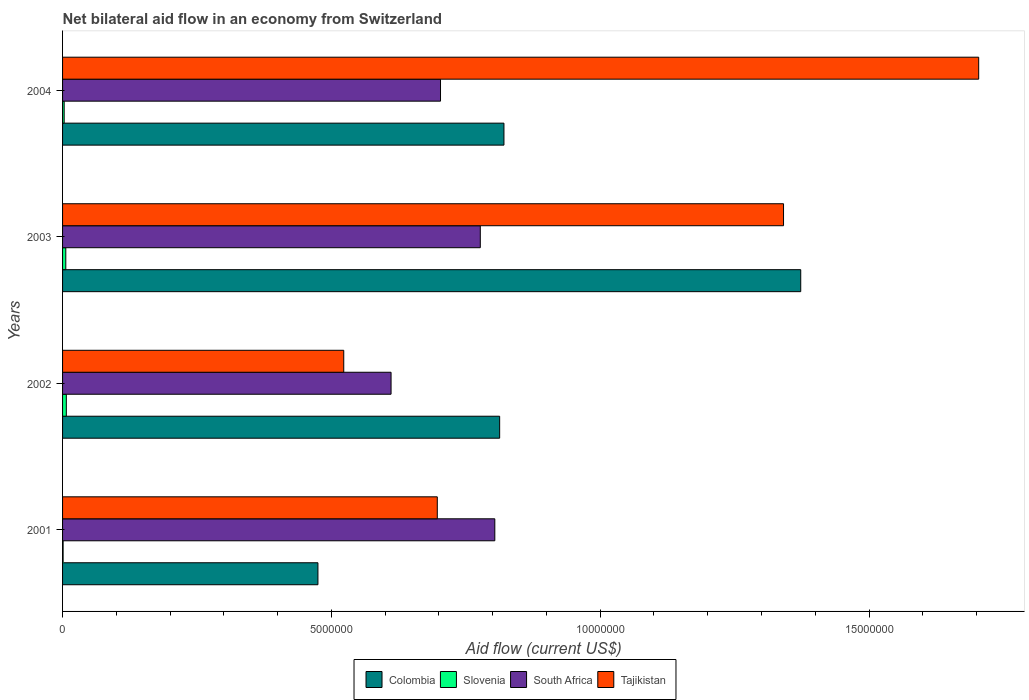How many groups of bars are there?
Ensure brevity in your answer.  4. Are the number of bars per tick equal to the number of legend labels?
Offer a terse response. Yes. How many bars are there on the 1st tick from the bottom?
Make the answer very short. 4. What is the label of the 4th group of bars from the top?
Make the answer very short. 2001. What is the net bilateral aid flow in Slovenia in 2003?
Provide a short and direct response. 6.00e+04. Across all years, what is the maximum net bilateral aid flow in Slovenia?
Provide a succinct answer. 7.00e+04. Across all years, what is the minimum net bilateral aid flow in South Africa?
Provide a succinct answer. 6.11e+06. In which year was the net bilateral aid flow in South Africa minimum?
Ensure brevity in your answer.  2002. What is the total net bilateral aid flow in South Africa in the graph?
Your response must be concise. 2.90e+07. What is the difference between the net bilateral aid flow in South Africa in 2002 and that in 2003?
Your answer should be very brief. -1.66e+06. What is the difference between the net bilateral aid flow in Colombia in 2001 and the net bilateral aid flow in Tajikistan in 2003?
Provide a succinct answer. -8.66e+06. What is the average net bilateral aid flow in South Africa per year?
Your response must be concise. 7.24e+06. In the year 2002, what is the difference between the net bilateral aid flow in Slovenia and net bilateral aid flow in Tajikistan?
Offer a terse response. -5.16e+06. What is the ratio of the net bilateral aid flow in Slovenia in 2002 to that in 2003?
Ensure brevity in your answer.  1.17. Is the net bilateral aid flow in Colombia in 2001 less than that in 2002?
Make the answer very short. Yes. Is the difference between the net bilateral aid flow in Slovenia in 2001 and 2003 greater than the difference between the net bilateral aid flow in Tajikistan in 2001 and 2003?
Offer a very short reply. Yes. What is the difference between the highest and the second highest net bilateral aid flow in Colombia?
Your answer should be compact. 5.52e+06. Is the sum of the net bilateral aid flow in Tajikistan in 2001 and 2002 greater than the maximum net bilateral aid flow in South Africa across all years?
Provide a short and direct response. Yes. Is it the case that in every year, the sum of the net bilateral aid flow in Tajikistan and net bilateral aid flow in Slovenia is greater than the sum of net bilateral aid flow in Colombia and net bilateral aid flow in South Africa?
Make the answer very short. No. What does the 1st bar from the top in 2004 represents?
Your answer should be compact. Tajikistan. What does the 3rd bar from the bottom in 2004 represents?
Offer a very short reply. South Africa. Is it the case that in every year, the sum of the net bilateral aid flow in Tajikistan and net bilateral aid flow in South Africa is greater than the net bilateral aid flow in Slovenia?
Ensure brevity in your answer.  Yes. How many years are there in the graph?
Make the answer very short. 4. Where does the legend appear in the graph?
Offer a very short reply. Bottom center. How are the legend labels stacked?
Provide a short and direct response. Horizontal. What is the title of the graph?
Keep it short and to the point. Net bilateral aid flow in an economy from Switzerland. Does "Uganda" appear as one of the legend labels in the graph?
Offer a very short reply. No. What is the label or title of the X-axis?
Provide a succinct answer. Aid flow (current US$). What is the label or title of the Y-axis?
Give a very brief answer. Years. What is the Aid flow (current US$) in Colombia in 2001?
Keep it short and to the point. 4.75e+06. What is the Aid flow (current US$) of Slovenia in 2001?
Provide a succinct answer. 10000. What is the Aid flow (current US$) of South Africa in 2001?
Offer a very short reply. 8.04e+06. What is the Aid flow (current US$) of Tajikistan in 2001?
Your answer should be compact. 6.97e+06. What is the Aid flow (current US$) in Colombia in 2002?
Your answer should be very brief. 8.13e+06. What is the Aid flow (current US$) in South Africa in 2002?
Give a very brief answer. 6.11e+06. What is the Aid flow (current US$) in Tajikistan in 2002?
Provide a short and direct response. 5.23e+06. What is the Aid flow (current US$) in Colombia in 2003?
Provide a short and direct response. 1.37e+07. What is the Aid flow (current US$) of South Africa in 2003?
Give a very brief answer. 7.77e+06. What is the Aid flow (current US$) in Tajikistan in 2003?
Your answer should be very brief. 1.34e+07. What is the Aid flow (current US$) of Colombia in 2004?
Your answer should be very brief. 8.21e+06. What is the Aid flow (current US$) of South Africa in 2004?
Offer a terse response. 7.03e+06. What is the Aid flow (current US$) of Tajikistan in 2004?
Provide a short and direct response. 1.70e+07. Across all years, what is the maximum Aid flow (current US$) in Colombia?
Provide a succinct answer. 1.37e+07. Across all years, what is the maximum Aid flow (current US$) of Slovenia?
Provide a short and direct response. 7.00e+04. Across all years, what is the maximum Aid flow (current US$) in South Africa?
Make the answer very short. 8.04e+06. Across all years, what is the maximum Aid flow (current US$) of Tajikistan?
Offer a very short reply. 1.70e+07. Across all years, what is the minimum Aid flow (current US$) of Colombia?
Your answer should be compact. 4.75e+06. Across all years, what is the minimum Aid flow (current US$) of South Africa?
Your answer should be very brief. 6.11e+06. Across all years, what is the minimum Aid flow (current US$) of Tajikistan?
Your answer should be compact. 5.23e+06. What is the total Aid flow (current US$) of Colombia in the graph?
Provide a short and direct response. 3.48e+07. What is the total Aid flow (current US$) in South Africa in the graph?
Offer a very short reply. 2.90e+07. What is the total Aid flow (current US$) of Tajikistan in the graph?
Provide a short and direct response. 4.26e+07. What is the difference between the Aid flow (current US$) in Colombia in 2001 and that in 2002?
Your response must be concise. -3.38e+06. What is the difference between the Aid flow (current US$) of South Africa in 2001 and that in 2002?
Provide a succinct answer. 1.93e+06. What is the difference between the Aid flow (current US$) of Tajikistan in 2001 and that in 2002?
Give a very brief answer. 1.74e+06. What is the difference between the Aid flow (current US$) in Colombia in 2001 and that in 2003?
Offer a very short reply. -8.98e+06. What is the difference between the Aid flow (current US$) of Slovenia in 2001 and that in 2003?
Give a very brief answer. -5.00e+04. What is the difference between the Aid flow (current US$) of Tajikistan in 2001 and that in 2003?
Your response must be concise. -6.44e+06. What is the difference between the Aid flow (current US$) of Colombia in 2001 and that in 2004?
Your response must be concise. -3.46e+06. What is the difference between the Aid flow (current US$) in South Africa in 2001 and that in 2004?
Ensure brevity in your answer.  1.01e+06. What is the difference between the Aid flow (current US$) in Tajikistan in 2001 and that in 2004?
Provide a short and direct response. -1.01e+07. What is the difference between the Aid flow (current US$) in Colombia in 2002 and that in 2003?
Your response must be concise. -5.60e+06. What is the difference between the Aid flow (current US$) in Slovenia in 2002 and that in 2003?
Offer a terse response. 10000. What is the difference between the Aid flow (current US$) in South Africa in 2002 and that in 2003?
Your answer should be compact. -1.66e+06. What is the difference between the Aid flow (current US$) in Tajikistan in 2002 and that in 2003?
Offer a terse response. -8.18e+06. What is the difference between the Aid flow (current US$) of Colombia in 2002 and that in 2004?
Your answer should be very brief. -8.00e+04. What is the difference between the Aid flow (current US$) in Slovenia in 2002 and that in 2004?
Provide a short and direct response. 4.00e+04. What is the difference between the Aid flow (current US$) of South Africa in 2002 and that in 2004?
Your response must be concise. -9.20e+05. What is the difference between the Aid flow (current US$) of Tajikistan in 2002 and that in 2004?
Make the answer very short. -1.18e+07. What is the difference between the Aid flow (current US$) of Colombia in 2003 and that in 2004?
Keep it short and to the point. 5.52e+06. What is the difference between the Aid flow (current US$) in Slovenia in 2003 and that in 2004?
Your answer should be very brief. 3.00e+04. What is the difference between the Aid flow (current US$) of South Africa in 2003 and that in 2004?
Provide a short and direct response. 7.40e+05. What is the difference between the Aid flow (current US$) in Tajikistan in 2003 and that in 2004?
Offer a terse response. -3.63e+06. What is the difference between the Aid flow (current US$) of Colombia in 2001 and the Aid flow (current US$) of Slovenia in 2002?
Give a very brief answer. 4.68e+06. What is the difference between the Aid flow (current US$) of Colombia in 2001 and the Aid flow (current US$) of South Africa in 2002?
Keep it short and to the point. -1.36e+06. What is the difference between the Aid flow (current US$) in Colombia in 2001 and the Aid flow (current US$) in Tajikistan in 2002?
Offer a very short reply. -4.80e+05. What is the difference between the Aid flow (current US$) of Slovenia in 2001 and the Aid flow (current US$) of South Africa in 2002?
Give a very brief answer. -6.10e+06. What is the difference between the Aid flow (current US$) in Slovenia in 2001 and the Aid flow (current US$) in Tajikistan in 2002?
Keep it short and to the point. -5.22e+06. What is the difference between the Aid flow (current US$) in South Africa in 2001 and the Aid flow (current US$) in Tajikistan in 2002?
Your response must be concise. 2.81e+06. What is the difference between the Aid flow (current US$) in Colombia in 2001 and the Aid flow (current US$) in Slovenia in 2003?
Make the answer very short. 4.69e+06. What is the difference between the Aid flow (current US$) in Colombia in 2001 and the Aid flow (current US$) in South Africa in 2003?
Your answer should be very brief. -3.02e+06. What is the difference between the Aid flow (current US$) in Colombia in 2001 and the Aid flow (current US$) in Tajikistan in 2003?
Your answer should be very brief. -8.66e+06. What is the difference between the Aid flow (current US$) in Slovenia in 2001 and the Aid flow (current US$) in South Africa in 2003?
Provide a short and direct response. -7.76e+06. What is the difference between the Aid flow (current US$) of Slovenia in 2001 and the Aid flow (current US$) of Tajikistan in 2003?
Your answer should be compact. -1.34e+07. What is the difference between the Aid flow (current US$) of South Africa in 2001 and the Aid flow (current US$) of Tajikistan in 2003?
Provide a short and direct response. -5.37e+06. What is the difference between the Aid flow (current US$) in Colombia in 2001 and the Aid flow (current US$) in Slovenia in 2004?
Your response must be concise. 4.72e+06. What is the difference between the Aid flow (current US$) in Colombia in 2001 and the Aid flow (current US$) in South Africa in 2004?
Keep it short and to the point. -2.28e+06. What is the difference between the Aid flow (current US$) in Colombia in 2001 and the Aid flow (current US$) in Tajikistan in 2004?
Give a very brief answer. -1.23e+07. What is the difference between the Aid flow (current US$) of Slovenia in 2001 and the Aid flow (current US$) of South Africa in 2004?
Provide a short and direct response. -7.02e+06. What is the difference between the Aid flow (current US$) in Slovenia in 2001 and the Aid flow (current US$) in Tajikistan in 2004?
Make the answer very short. -1.70e+07. What is the difference between the Aid flow (current US$) in South Africa in 2001 and the Aid flow (current US$) in Tajikistan in 2004?
Offer a terse response. -9.00e+06. What is the difference between the Aid flow (current US$) of Colombia in 2002 and the Aid flow (current US$) of Slovenia in 2003?
Give a very brief answer. 8.07e+06. What is the difference between the Aid flow (current US$) of Colombia in 2002 and the Aid flow (current US$) of South Africa in 2003?
Your response must be concise. 3.60e+05. What is the difference between the Aid flow (current US$) in Colombia in 2002 and the Aid flow (current US$) in Tajikistan in 2003?
Your answer should be compact. -5.28e+06. What is the difference between the Aid flow (current US$) in Slovenia in 2002 and the Aid flow (current US$) in South Africa in 2003?
Provide a succinct answer. -7.70e+06. What is the difference between the Aid flow (current US$) of Slovenia in 2002 and the Aid flow (current US$) of Tajikistan in 2003?
Offer a very short reply. -1.33e+07. What is the difference between the Aid flow (current US$) in South Africa in 2002 and the Aid flow (current US$) in Tajikistan in 2003?
Keep it short and to the point. -7.30e+06. What is the difference between the Aid flow (current US$) in Colombia in 2002 and the Aid flow (current US$) in Slovenia in 2004?
Give a very brief answer. 8.10e+06. What is the difference between the Aid flow (current US$) of Colombia in 2002 and the Aid flow (current US$) of South Africa in 2004?
Give a very brief answer. 1.10e+06. What is the difference between the Aid flow (current US$) in Colombia in 2002 and the Aid flow (current US$) in Tajikistan in 2004?
Provide a short and direct response. -8.91e+06. What is the difference between the Aid flow (current US$) in Slovenia in 2002 and the Aid flow (current US$) in South Africa in 2004?
Give a very brief answer. -6.96e+06. What is the difference between the Aid flow (current US$) in Slovenia in 2002 and the Aid flow (current US$) in Tajikistan in 2004?
Your answer should be very brief. -1.70e+07. What is the difference between the Aid flow (current US$) of South Africa in 2002 and the Aid flow (current US$) of Tajikistan in 2004?
Provide a short and direct response. -1.09e+07. What is the difference between the Aid flow (current US$) in Colombia in 2003 and the Aid flow (current US$) in Slovenia in 2004?
Offer a terse response. 1.37e+07. What is the difference between the Aid flow (current US$) of Colombia in 2003 and the Aid flow (current US$) of South Africa in 2004?
Provide a succinct answer. 6.70e+06. What is the difference between the Aid flow (current US$) in Colombia in 2003 and the Aid flow (current US$) in Tajikistan in 2004?
Provide a succinct answer. -3.31e+06. What is the difference between the Aid flow (current US$) of Slovenia in 2003 and the Aid flow (current US$) of South Africa in 2004?
Provide a succinct answer. -6.97e+06. What is the difference between the Aid flow (current US$) of Slovenia in 2003 and the Aid flow (current US$) of Tajikistan in 2004?
Your answer should be compact. -1.70e+07. What is the difference between the Aid flow (current US$) of South Africa in 2003 and the Aid flow (current US$) of Tajikistan in 2004?
Keep it short and to the point. -9.27e+06. What is the average Aid flow (current US$) of Colombia per year?
Your answer should be very brief. 8.70e+06. What is the average Aid flow (current US$) in Slovenia per year?
Provide a succinct answer. 4.25e+04. What is the average Aid flow (current US$) in South Africa per year?
Keep it short and to the point. 7.24e+06. What is the average Aid flow (current US$) of Tajikistan per year?
Make the answer very short. 1.07e+07. In the year 2001, what is the difference between the Aid flow (current US$) in Colombia and Aid flow (current US$) in Slovenia?
Your answer should be very brief. 4.74e+06. In the year 2001, what is the difference between the Aid flow (current US$) in Colombia and Aid flow (current US$) in South Africa?
Your answer should be compact. -3.29e+06. In the year 2001, what is the difference between the Aid flow (current US$) of Colombia and Aid flow (current US$) of Tajikistan?
Ensure brevity in your answer.  -2.22e+06. In the year 2001, what is the difference between the Aid flow (current US$) in Slovenia and Aid flow (current US$) in South Africa?
Keep it short and to the point. -8.03e+06. In the year 2001, what is the difference between the Aid flow (current US$) in Slovenia and Aid flow (current US$) in Tajikistan?
Your answer should be compact. -6.96e+06. In the year 2001, what is the difference between the Aid flow (current US$) of South Africa and Aid flow (current US$) of Tajikistan?
Keep it short and to the point. 1.07e+06. In the year 2002, what is the difference between the Aid flow (current US$) of Colombia and Aid flow (current US$) of Slovenia?
Provide a succinct answer. 8.06e+06. In the year 2002, what is the difference between the Aid flow (current US$) in Colombia and Aid flow (current US$) in South Africa?
Offer a very short reply. 2.02e+06. In the year 2002, what is the difference between the Aid flow (current US$) of Colombia and Aid flow (current US$) of Tajikistan?
Provide a short and direct response. 2.90e+06. In the year 2002, what is the difference between the Aid flow (current US$) in Slovenia and Aid flow (current US$) in South Africa?
Your answer should be very brief. -6.04e+06. In the year 2002, what is the difference between the Aid flow (current US$) in Slovenia and Aid flow (current US$) in Tajikistan?
Your answer should be compact. -5.16e+06. In the year 2002, what is the difference between the Aid flow (current US$) in South Africa and Aid flow (current US$) in Tajikistan?
Offer a terse response. 8.80e+05. In the year 2003, what is the difference between the Aid flow (current US$) in Colombia and Aid flow (current US$) in Slovenia?
Offer a very short reply. 1.37e+07. In the year 2003, what is the difference between the Aid flow (current US$) of Colombia and Aid flow (current US$) of South Africa?
Ensure brevity in your answer.  5.96e+06. In the year 2003, what is the difference between the Aid flow (current US$) of Slovenia and Aid flow (current US$) of South Africa?
Provide a short and direct response. -7.71e+06. In the year 2003, what is the difference between the Aid flow (current US$) of Slovenia and Aid flow (current US$) of Tajikistan?
Your answer should be compact. -1.34e+07. In the year 2003, what is the difference between the Aid flow (current US$) in South Africa and Aid flow (current US$) in Tajikistan?
Ensure brevity in your answer.  -5.64e+06. In the year 2004, what is the difference between the Aid flow (current US$) in Colombia and Aid flow (current US$) in Slovenia?
Give a very brief answer. 8.18e+06. In the year 2004, what is the difference between the Aid flow (current US$) of Colombia and Aid flow (current US$) of South Africa?
Provide a short and direct response. 1.18e+06. In the year 2004, what is the difference between the Aid flow (current US$) of Colombia and Aid flow (current US$) of Tajikistan?
Provide a short and direct response. -8.83e+06. In the year 2004, what is the difference between the Aid flow (current US$) of Slovenia and Aid flow (current US$) of South Africa?
Your answer should be very brief. -7.00e+06. In the year 2004, what is the difference between the Aid flow (current US$) of Slovenia and Aid flow (current US$) of Tajikistan?
Make the answer very short. -1.70e+07. In the year 2004, what is the difference between the Aid flow (current US$) of South Africa and Aid flow (current US$) of Tajikistan?
Make the answer very short. -1.00e+07. What is the ratio of the Aid flow (current US$) of Colombia in 2001 to that in 2002?
Offer a very short reply. 0.58. What is the ratio of the Aid flow (current US$) of Slovenia in 2001 to that in 2002?
Your answer should be very brief. 0.14. What is the ratio of the Aid flow (current US$) in South Africa in 2001 to that in 2002?
Make the answer very short. 1.32. What is the ratio of the Aid flow (current US$) of Tajikistan in 2001 to that in 2002?
Provide a short and direct response. 1.33. What is the ratio of the Aid flow (current US$) of Colombia in 2001 to that in 2003?
Make the answer very short. 0.35. What is the ratio of the Aid flow (current US$) of South Africa in 2001 to that in 2003?
Your answer should be very brief. 1.03. What is the ratio of the Aid flow (current US$) in Tajikistan in 2001 to that in 2003?
Provide a succinct answer. 0.52. What is the ratio of the Aid flow (current US$) of Colombia in 2001 to that in 2004?
Your answer should be very brief. 0.58. What is the ratio of the Aid flow (current US$) of Slovenia in 2001 to that in 2004?
Your answer should be very brief. 0.33. What is the ratio of the Aid flow (current US$) in South Africa in 2001 to that in 2004?
Offer a terse response. 1.14. What is the ratio of the Aid flow (current US$) of Tajikistan in 2001 to that in 2004?
Make the answer very short. 0.41. What is the ratio of the Aid flow (current US$) in Colombia in 2002 to that in 2003?
Make the answer very short. 0.59. What is the ratio of the Aid flow (current US$) of Slovenia in 2002 to that in 2003?
Provide a short and direct response. 1.17. What is the ratio of the Aid flow (current US$) of South Africa in 2002 to that in 2003?
Offer a very short reply. 0.79. What is the ratio of the Aid flow (current US$) in Tajikistan in 2002 to that in 2003?
Your response must be concise. 0.39. What is the ratio of the Aid flow (current US$) in Colombia in 2002 to that in 2004?
Your response must be concise. 0.99. What is the ratio of the Aid flow (current US$) in Slovenia in 2002 to that in 2004?
Give a very brief answer. 2.33. What is the ratio of the Aid flow (current US$) of South Africa in 2002 to that in 2004?
Give a very brief answer. 0.87. What is the ratio of the Aid flow (current US$) in Tajikistan in 2002 to that in 2004?
Offer a very short reply. 0.31. What is the ratio of the Aid flow (current US$) in Colombia in 2003 to that in 2004?
Ensure brevity in your answer.  1.67. What is the ratio of the Aid flow (current US$) in Slovenia in 2003 to that in 2004?
Your answer should be compact. 2. What is the ratio of the Aid flow (current US$) of South Africa in 2003 to that in 2004?
Give a very brief answer. 1.11. What is the ratio of the Aid flow (current US$) of Tajikistan in 2003 to that in 2004?
Provide a succinct answer. 0.79. What is the difference between the highest and the second highest Aid flow (current US$) of Colombia?
Provide a succinct answer. 5.52e+06. What is the difference between the highest and the second highest Aid flow (current US$) of Slovenia?
Your response must be concise. 10000. What is the difference between the highest and the second highest Aid flow (current US$) of South Africa?
Offer a terse response. 2.70e+05. What is the difference between the highest and the second highest Aid flow (current US$) in Tajikistan?
Your answer should be very brief. 3.63e+06. What is the difference between the highest and the lowest Aid flow (current US$) in Colombia?
Keep it short and to the point. 8.98e+06. What is the difference between the highest and the lowest Aid flow (current US$) of Slovenia?
Make the answer very short. 6.00e+04. What is the difference between the highest and the lowest Aid flow (current US$) in South Africa?
Provide a short and direct response. 1.93e+06. What is the difference between the highest and the lowest Aid flow (current US$) of Tajikistan?
Your response must be concise. 1.18e+07. 